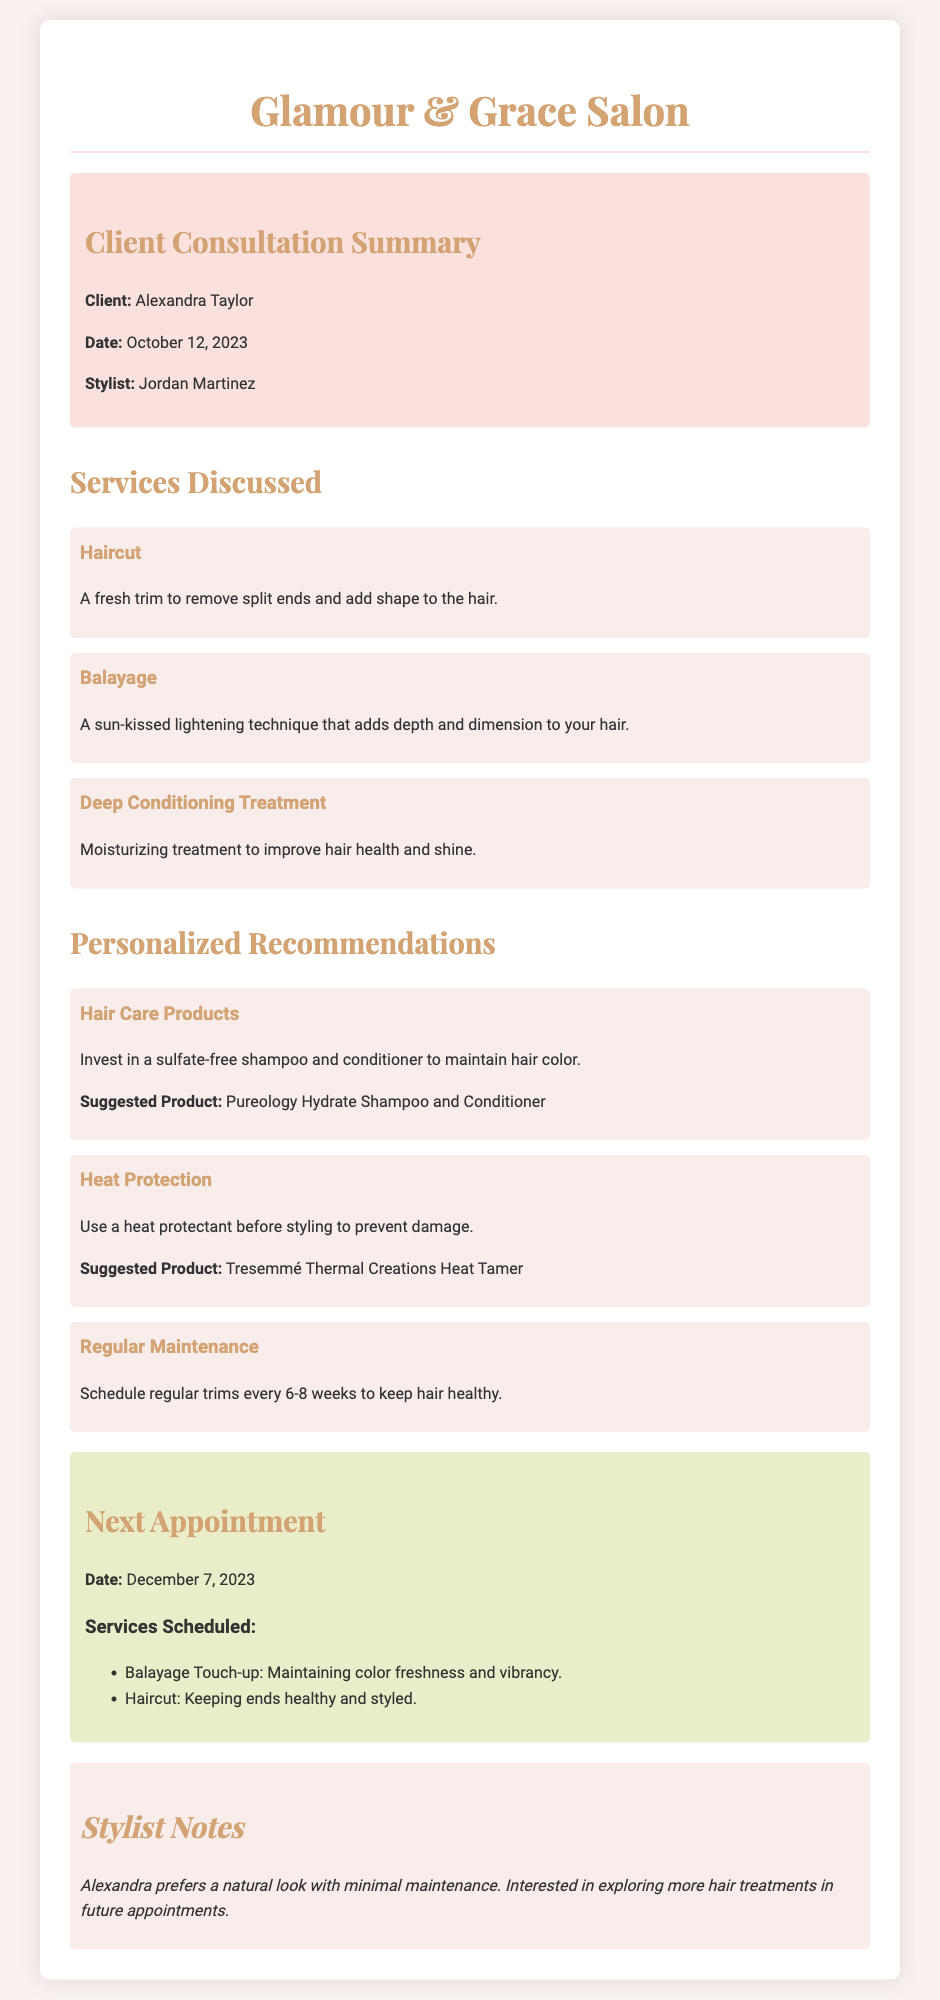What is the client's name? The client's name is mentioned in the client information section of the document.
Answer: Alexandra Taylor Who is the stylist assigned to the client? The name of the stylist can be found in the client information section of the document.
Answer: Jordan Martinez What date is the next appointment scheduled for? The next appointment date is specified in the next appointment section.
Answer: December 7, 2023 Which product is suggested for heat protection? The suggested product for heat protection is listed in the personalized recommendations section.
Answer: Tresemmé Thermal Creations Heat Tamer How often should regular trims be scheduled? The document mentions the frequency of regular trims in the personalized recommendations section.
Answer: Every 6-8 weeks What services are scheduled for the next appointment? The services for the next appointment are listed under the next appointment section.
Answer: Balayage Touch-up, Haircut What treatment focuses on improving hair health and shine? The specific treatment aimed at enhancing hair health is highlighted in the services discussed section.
Answer: Deep Conditioning Treatment What look does Alexandra prefer according to stylist notes? The stylist notes provide information about Alexandra's preferences.
Answer: Natural look 